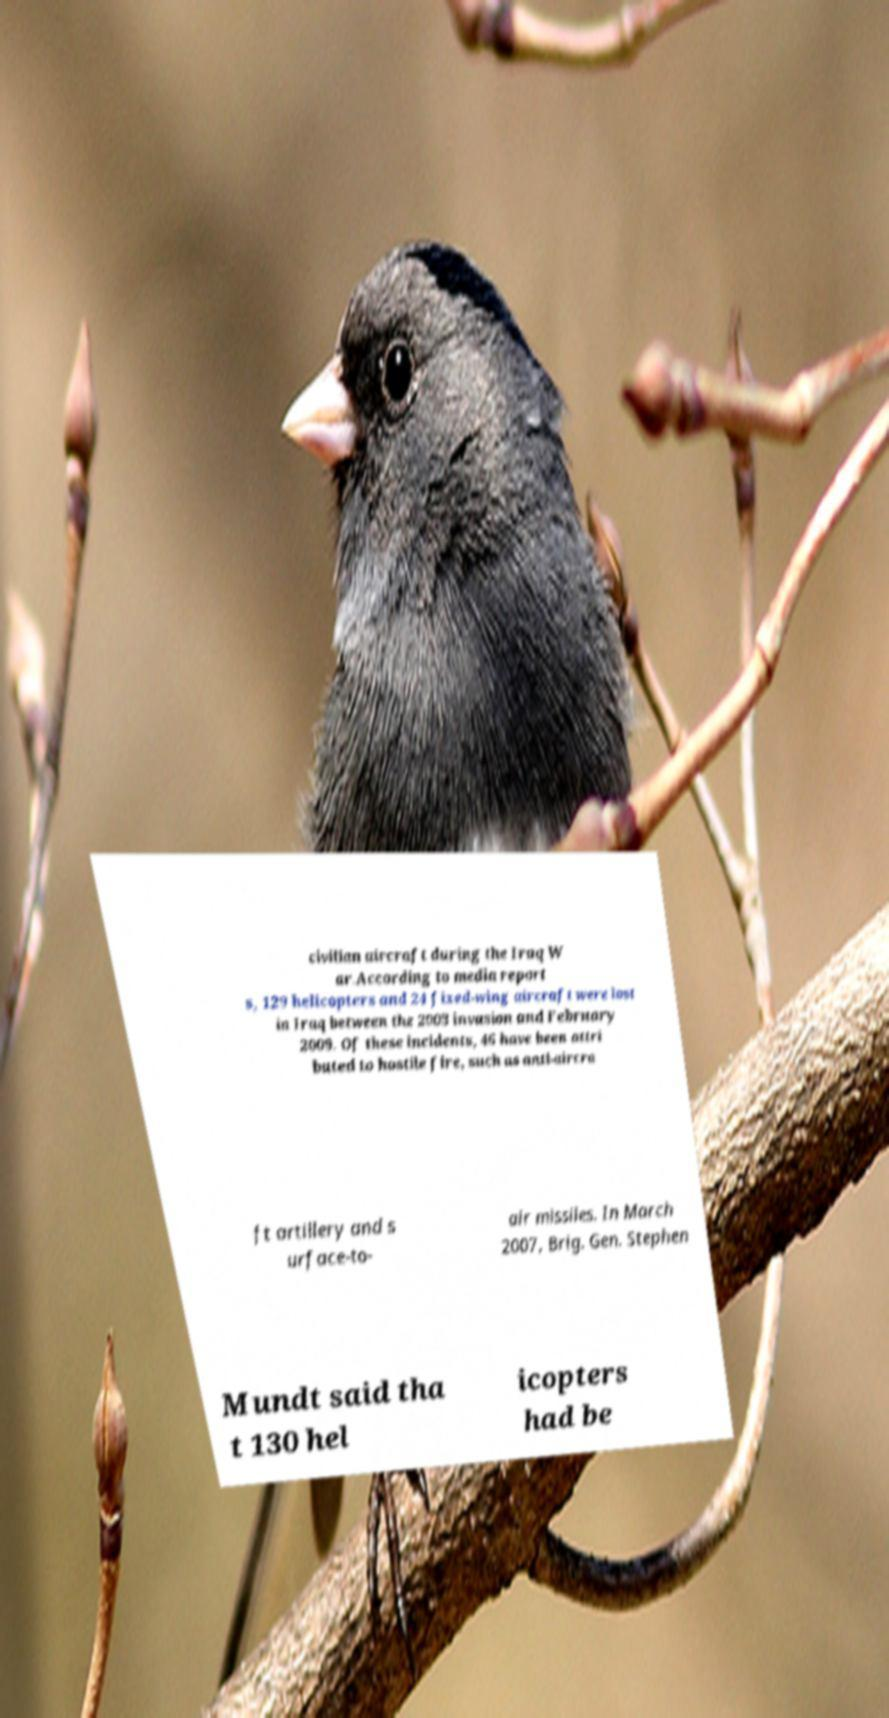Could you extract and type out the text from this image? civilian aircraft during the Iraq W ar.According to media report s, 129 helicopters and 24 fixed-wing aircraft were lost in Iraq between the 2003 invasion and February 2009. Of these incidents, 46 have been attri buted to hostile fire, such as anti-aircra ft artillery and s urface-to- air missiles. In March 2007, Brig. Gen. Stephen Mundt said tha t 130 hel icopters had be 